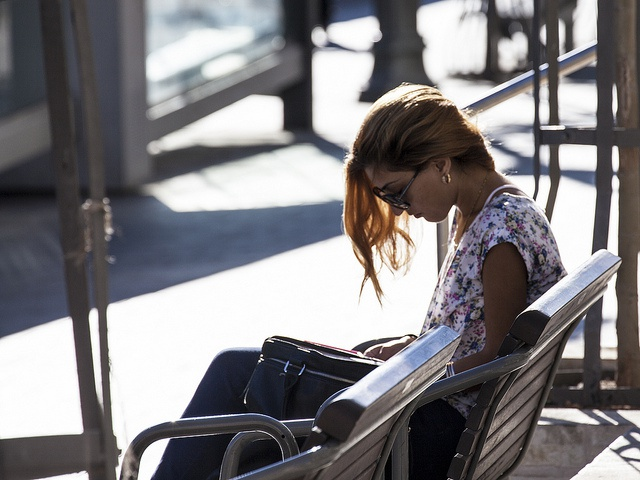Describe the objects in this image and their specific colors. I can see people in black, maroon, white, and gray tones, chair in black, gray, white, and darkgray tones, chair in black, gray, lightgray, and darkgray tones, and backpack in black, gray, white, and darkgray tones in this image. 